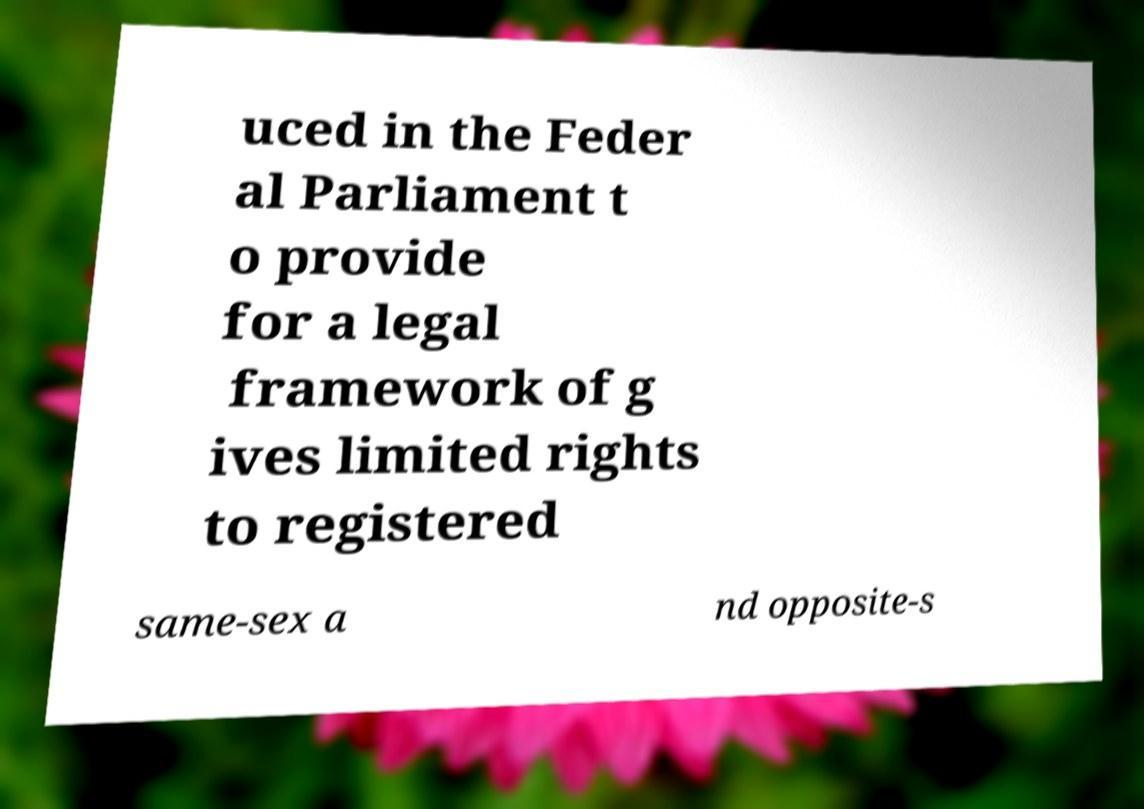I need the written content from this picture converted into text. Can you do that? uced in the Feder al Parliament t o provide for a legal framework of g ives limited rights to registered same-sex a nd opposite-s 